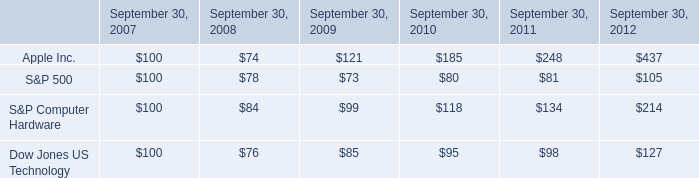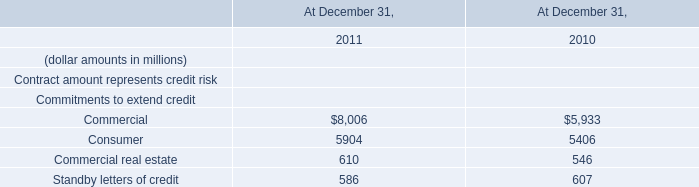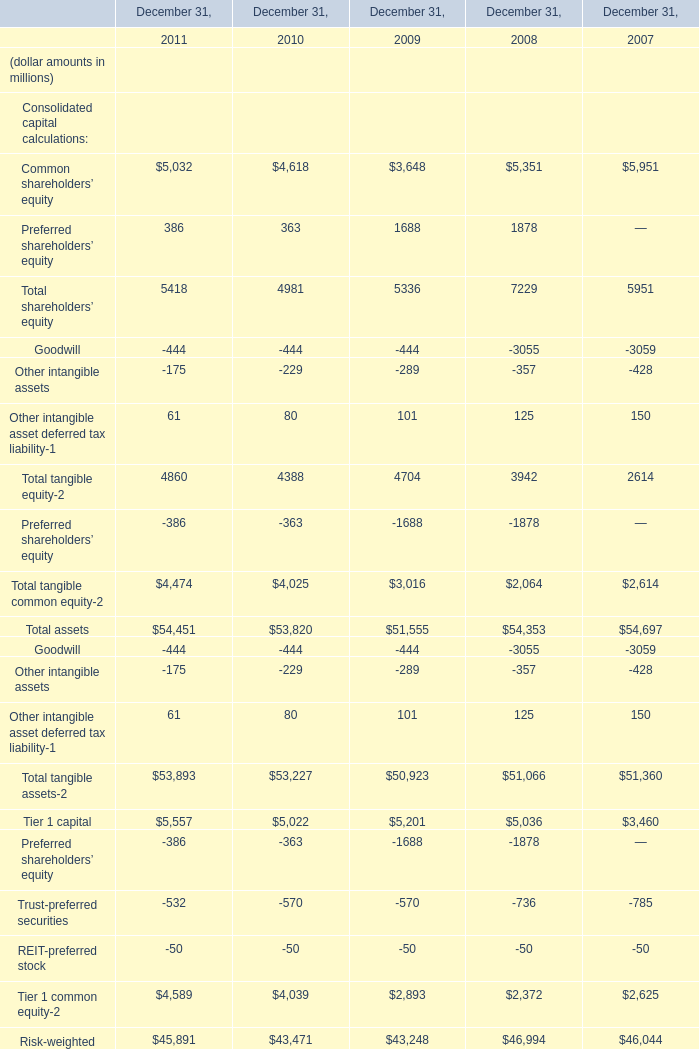What's the average of the Commercial for Commitments to extend credit in the years where Total tangible assets-2 is greater than 53000? (in million) 
Computations: ((8006 + 5933) / 2)
Answer: 6969.5. 